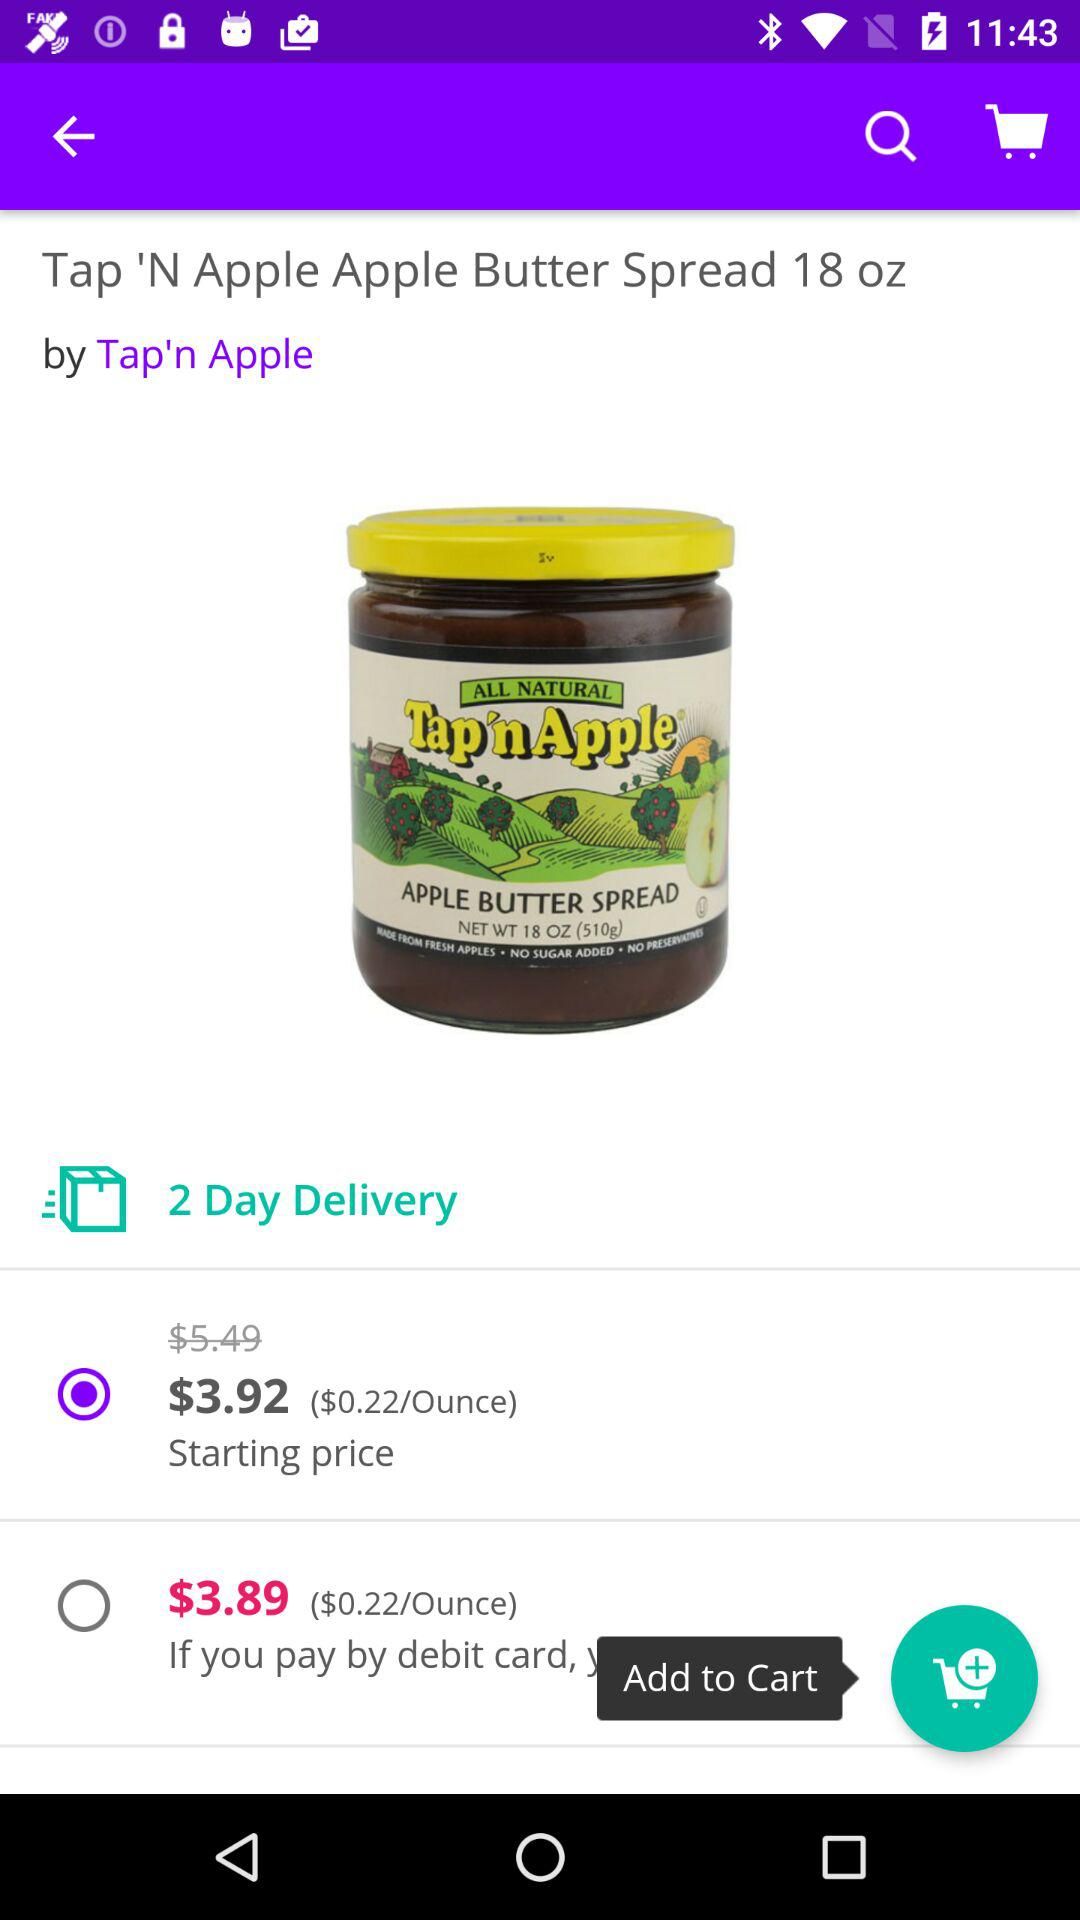What's the price of "Tap 'N Apple Apple Butter Spread" per ounce? The price of "Tap 'N Apple Apple Butter Spread" is $0.22 per ounce. 